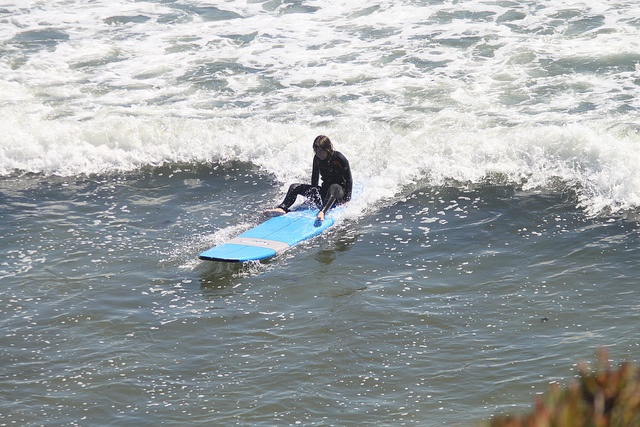Describe the objects in this image and their specific colors. I can see surfboard in white, lightblue, and lightgray tones and people in white, black, gray, and lightgray tones in this image. 